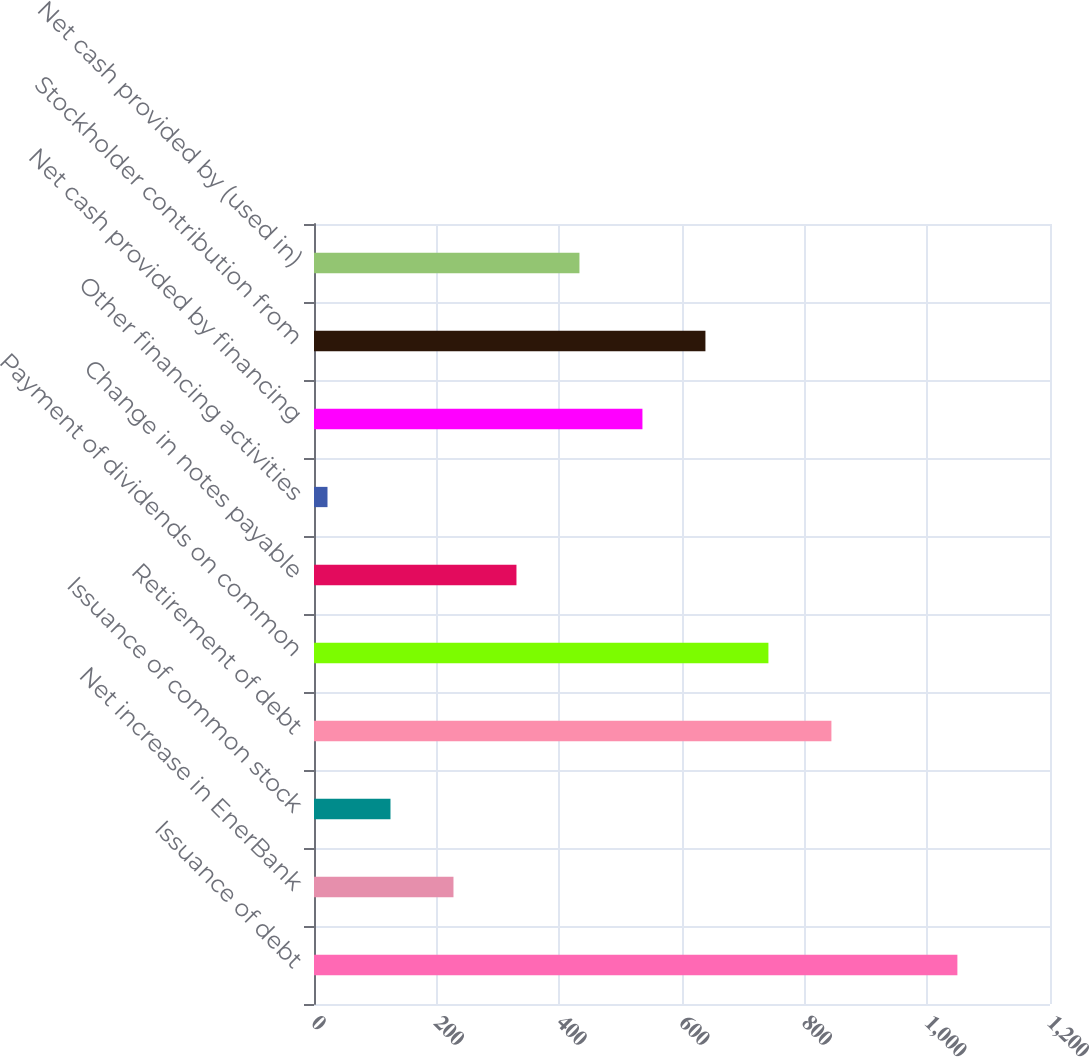<chart> <loc_0><loc_0><loc_500><loc_500><bar_chart><fcel>Issuance of debt<fcel>Net increase in EnerBank<fcel>Issuance of common stock<fcel>Retirement of debt<fcel>Payment of dividends on common<fcel>Change in notes payable<fcel>Other financing activities<fcel>Net cash provided by financing<fcel>Stockholder contribution from<fcel>Net cash provided by (used in)<nl><fcel>1049<fcel>227.4<fcel>124.7<fcel>843.6<fcel>740.9<fcel>330.1<fcel>22<fcel>535.5<fcel>638.2<fcel>432.8<nl></chart> 